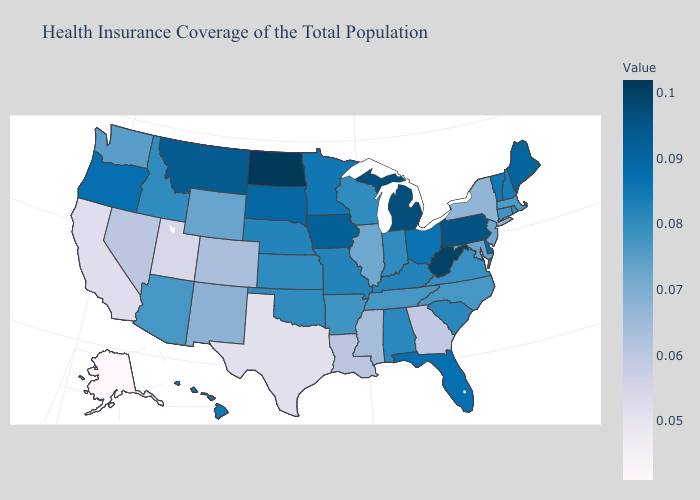Does the map have missing data?
Quick response, please. No. 